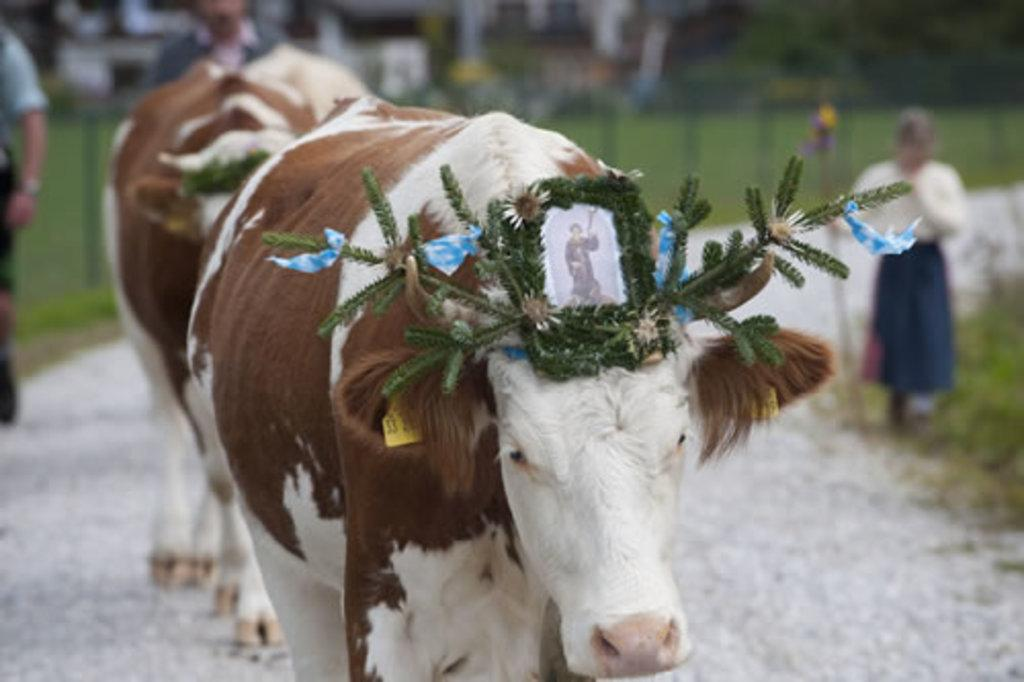What animal is the main subject of the image? There is a cow in the image. What items can be seen on or near the cow? The cow has a decorative object and a photo. Can you describe the background of the image? There are people visible in the background, along with a walkway and poles. The background has a blurred view. What type of clouds can be seen in the image? There are no clouds visible in the image. Is there a stick being used in a battle scene in the image? There is no stick or battle scene present in the image. 